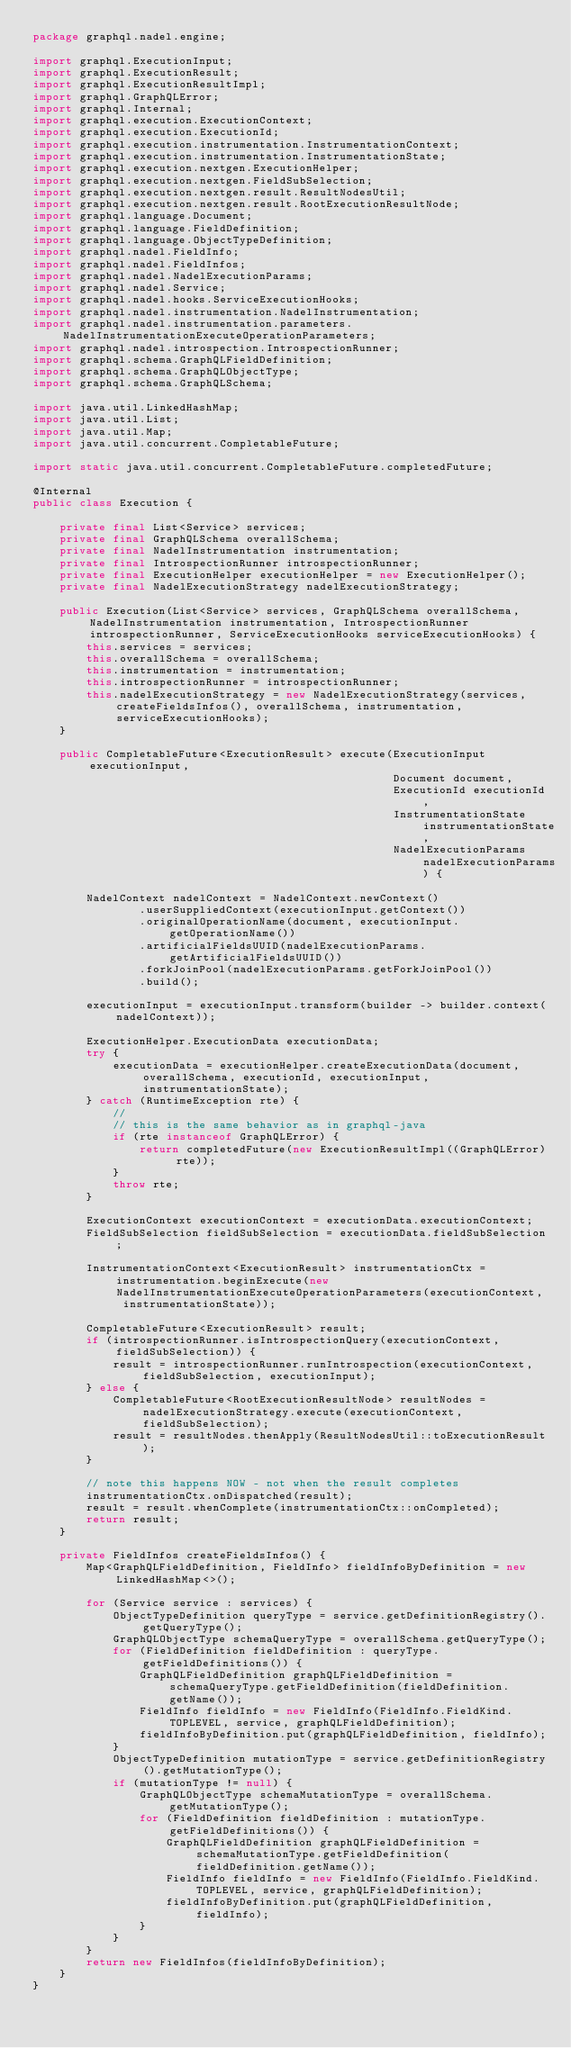<code> <loc_0><loc_0><loc_500><loc_500><_Java_>package graphql.nadel.engine;

import graphql.ExecutionInput;
import graphql.ExecutionResult;
import graphql.ExecutionResultImpl;
import graphql.GraphQLError;
import graphql.Internal;
import graphql.execution.ExecutionContext;
import graphql.execution.ExecutionId;
import graphql.execution.instrumentation.InstrumentationContext;
import graphql.execution.instrumentation.InstrumentationState;
import graphql.execution.nextgen.ExecutionHelper;
import graphql.execution.nextgen.FieldSubSelection;
import graphql.execution.nextgen.result.ResultNodesUtil;
import graphql.execution.nextgen.result.RootExecutionResultNode;
import graphql.language.Document;
import graphql.language.FieldDefinition;
import graphql.language.ObjectTypeDefinition;
import graphql.nadel.FieldInfo;
import graphql.nadel.FieldInfos;
import graphql.nadel.NadelExecutionParams;
import graphql.nadel.Service;
import graphql.nadel.hooks.ServiceExecutionHooks;
import graphql.nadel.instrumentation.NadelInstrumentation;
import graphql.nadel.instrumentation.parameters.NadelInstrumentationExecuteOperationParameters;
import graphql.nadel.introspection.IntrospectionRunner;
import graphql.schema.GraphQLFieldDefinition;
import graphql.schema.GraphQLObjectType;
import graphql.schema.GraphQLSchema;

import java.util.LinkedHashMap;
import java.util.List;
import java.util.Map;
import java.util.concurrent.CompletableFuture;

import static java.util.concurrent.CompletableFuture.completedFuture;

@Internal
public class Execution {

    private final List<Service> services;
    private final GraphQLSchema overallSchema;
    private final NadelInstrumentation instrumentation;
    private final IntrospectionRunner introspectionRunner;
    private final ExecutionHelper executionHelper = new ExecutionHelper();
    private final NadelExecutionStrategy nadelExecutionStrategy;

    public Execution(List<Service> services, GraphQLSchema overallSchema, NadelInstrumentation instrumentation, IntrospectionRunner introspectionRunner, ServiceExecutionHooks serviceExecutionHooks) {
        this.services = services;
        this.overallSchema = overallSchema;
        this.instrumentation = instrumentation;
        this.introspectionRunner = introspectionRunner;
        this.nadelExecutionStrategy = new NadelExecutionStrategy(services, createFieldsInfos(), overallSchema, instrumentation, serviceExecutionHooks);
    }

    public CompletableFuture<ExecutionResult> execute(ExecutionInput executionInput,
                                                      Document document,
                                                      ExecutionId executionId,
                                                      InstrumentationState instrumentationState,
                                                      NadelExecutionParams nadelExecutionParams) {

        NadelContext nadelContext = NadelContext.newContext()
                .userSuppliedContext(executionInput.getContext())
                .originalOperationName(document, executionInput.getOperationName())
                .artificialFieldsUUID(nadelExecutionParams.getArtificialFieldsUUID())
                .forkJoinPool(nadelExecutionParams.getForkJoinPool())
                .build();

        executionInput = executionInput.transform(builder -> builder.context(nadelContext));

        ExecutionHelper.ExecutionData executionData;
        try {
            executionData = executionHelper.createExecutionData(document, overallSchema, executionId, executionInput, instrumentationState);
        } catch (RuntimeException rte) {
            //
            // this is the same behavior as in graphql-java
            if (rte instanceof GraphQLError) {
                return completedFuture(new ExecutionResultImpl((GraphQLError) rte));
            }
            throw rte;
        }

        ExecutionContext executionContext = executionData.executionContext;
        FieldSubSelection fieldSubSelection = executionData.fieldSubSelection;

        InstrumentationContext<ExecutionResult> instrumentationCtx = instrumentation.beginExecute(new NadelInstrumentationExecuteOperationParameters(executionContext, instrumentationState));

        CompletableFuture<ExecutionResult> result;
        if (introspectionRunner.isIntrospectionQuery(executionContext, fieldSubSelection)) {
            result = introspectionRunner.runIntrospection(executionContext, fieldSubSelection, executionInput);
        } else {
            CompletableFuture<RootExecutionResultNode> resultNodes = nadelExecutionStrategy.execute(executionContext, fieldSubSelection);
            result = resultNodes.thenApply(ResultNodesUtil::toExecutionResult);
        }

        // note this happens NOW - not when the result completes
        instrumentationCtx.onDispatched(result);
        result = result.whenComplete(instrumentationCtx::onCompleted);
        return result;
    }

    private FieldInfos createFieldsInfos() {
        Map<GraphQLFieldDefinition, FieldInfo> fieldInfoByDefinition = new LinkedHashMap<>();

        for (Service service : services) {
            ObjectTypeDefinition queryType = service.getDefinitionRegistry().getQueryType();
            GraphQLObjectType schemaQueryType = overallSchema.getQueryType();
            for (FieldDefinition fieldDefinition : queryType.getFieldDefinitions()) {
                GraphQLFieldDefinition graphQLFieldDefinition = schemaQueryType.getFieldDefinition(fieldDefinition.getName());
                FieldInfo fieldInfo = new FieldInfo(FieldInfo.FieldKind.TOPLEVEL, service, graphQLFieldDefinition);
                fieldInfoByDefinition.put(graphQLFieldDefinition, fieldInfo);
            }
            ObjectTypeDefinition mutationType = service.getDefinitionRegistry().getMutationType();
            if (mutationType != null) {
                GraphQLObjectType schemaMutationType = overallSchema.getMutationType();
                for (FieldDefinition fieldDefinition : mutationType.getFieldDefinitions()) {
                    GraphQLFieldDefinition graphQLFieldDefinition = schemaMutationType.getFieldDefinition(fieldDefinition.getName());
                    FieldInfo fieldInfo = new FieldInfo(FieldInfo.FieldKind.TOPLEVEL, service, graphQLFieldDefinition);
                    fieldInfoByDefinition.put(graphQLFieldDefinition, fieldInfo);
                }
            }
        }
        return new FieldInfos(fieldInfoByDefinition);
    }
}
</code> 